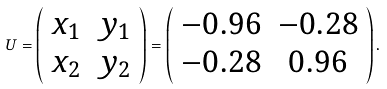<formula> <loc_0><loc_0><loc_500><loc_500>U = \left ( \begin{array} { c c } x _ { 1 } & y _ { 1 } \\ x _ { 2 } & y _ { 2 } \end{array} \right ) = \left ( \begin{array} { c c } - 0 . 9 6 & - 0 . 2 8 \\ - 0 . 2 8 & 0 . 9 6 \end{array} \right ) .</formula> 